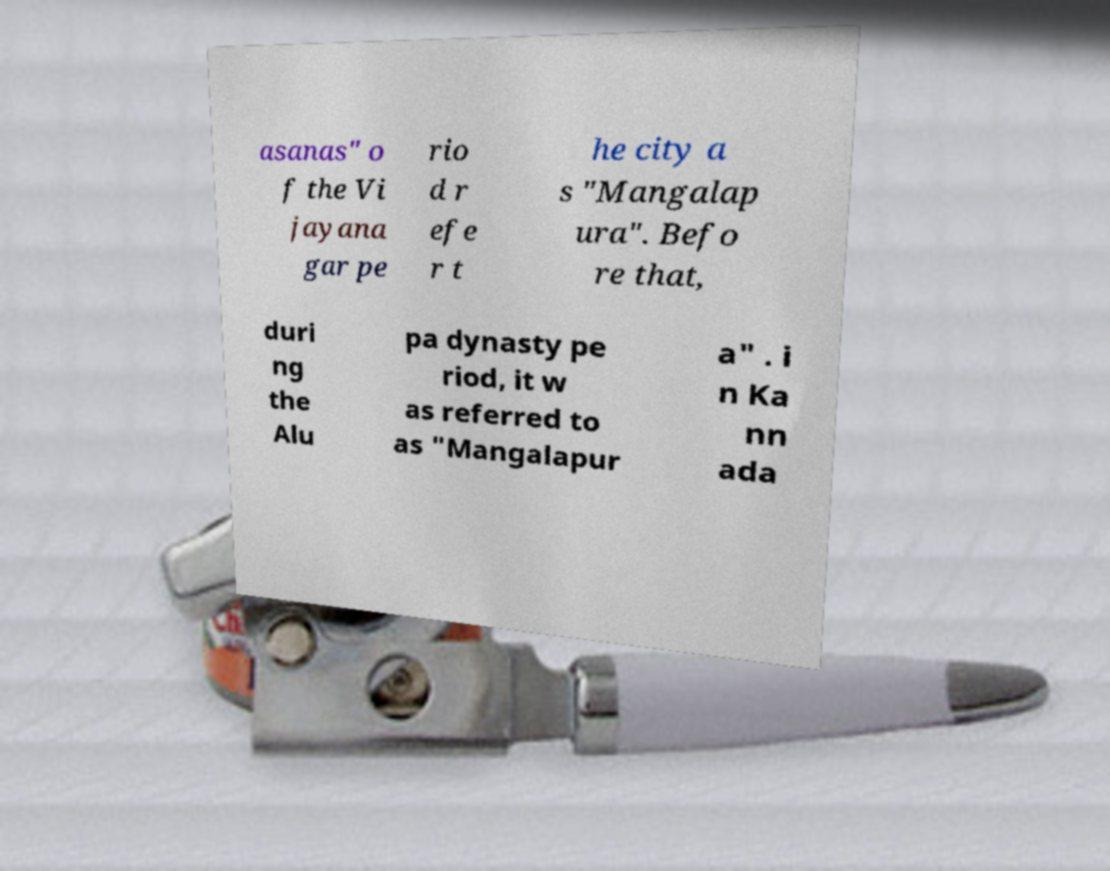For documentation purposes, I need the text within this image transcribed. Could you provide that? asanas" o f the Vi jayana gar pe rio d r efe r t he city a s "Mangalap ura". Befo re that, duri ng the Alu pa dynasty pe riod, it w as referred to as "Mangalapur a" . i n Ka nn ada 